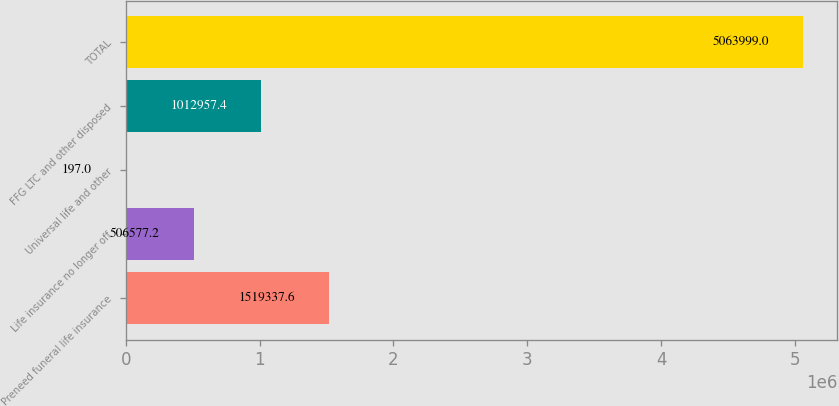Convert chart. <chart><loc_0><loc_0><loc_500><loc_500><bar_chart><fcel>Preneed funeral life insurance<fcel>Life insurance no longer off<fcel>Universal life and other<fcel>FFG LTC and other disposed<fcel>TOTAL<nl><fcel>1.51934e+06<fcel>506577<fcel>197<fcel>1.01296e+06<fcel>5.064e+06<nl></chart> 